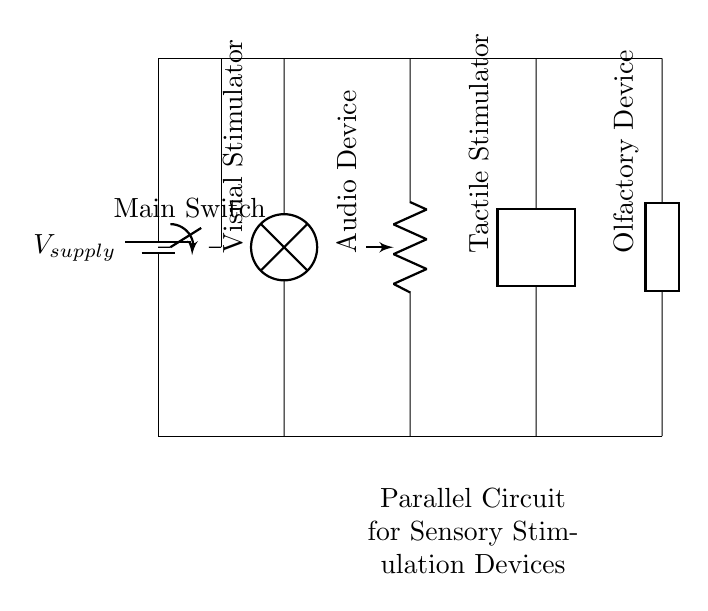What is the type of circuit shown? The circuit diagram depicts a parallel circuit, as evidenced by the presence of multiple components connected alongside each other to the same voltage source without being in series.
Answer: Parallel How many devices are connected in this circuit? Four devices are illustrated in the diagram, which are a visual stimulator, audio device, tactile stimulator, and olfactory device, all connected in parallel.
Answer: Four What is the purpose of the main switch? The main switch allows control over the entire circuit by either enabling or disabling the flow of electricity to all connected devices simultaneously, ensuring safety and ease of use.
Answer: Control Which device is likely to provide visual stimulation? The visual stimulator is indicated in the diagram by a lamp symbol and is labeled as such, clearly defining its function in sensory therapy.
Answer: Visual stimulator What effect does connecting devices in parallel have on voltage? In a parallel circuit, each device receives the full supply voltage from the source, providing uniform voltage across all connected components.
Answer: Full voltage Which component regulates audio sensation? The audio device is represented as a pR symbol in the diagram, identifying its function in the parallel circuit for providing auditory stimulation.
Answer: Audio device What does the label on the bottom signify? The label at the bottom, stating "Parallel Circuit for Sensory Stimulation Devices," indicates the purpose of the entire circuit, helping users understand its intended application in therapy.
Answer: Purpose 